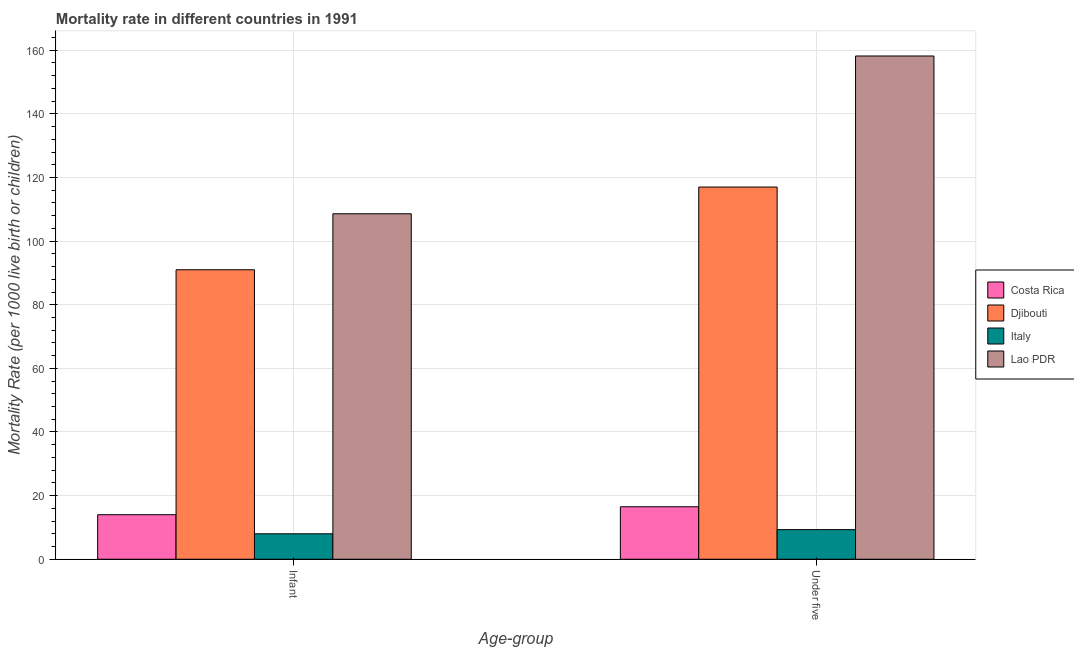How many groups of bars are there?
Provide a short and direct response. 2. Are the number of bars per tick equal to the number of legend labels?
Offer a very short reply. Yes. What is the label of the 1st group of bars from the left?
Provide a succinct answer. Infant. What is the infant mortality rate in Lao PDR?
Your response must be concise. 108.6. Across all countries, what is the maximum infant mortality rate?
Provide a succinct answer. 108.6. In which country was the under-5 mortality rate maximum?
Make the answer very short. Lao PDR. In which country was the under-5 mortality rate minimum?
Offer a terse response. Italy. What is the total under-5 mortality rate in the graph?
Keep it short and to the point. 301. What is the difference between the under-5 mortality rate in Lao PDR and the infant mortality rate in Costa Rica?
Give a very brief answer. 144.2. What is the average under-5 mortality rate per country?
Give a very brief answer. 75.25. What is the difference between the under-5 mortality rate and infant mortality rate in Lao PDR?
Your answer should be very brief. 49.6. In how many countries, is the under-5 mortality rate greater than 124 ?
Offer a very short reply. 1. What is the ratio of the under-5 mortality rate in Djibouti to that in Costa Rica?
Your response must be concise. 7.09. How many bars are there?
Provide a short and direct response. 8. Are all the bars in the graph horizontal?
Give a very brief answer. No. How many countries are there in the graph?
Offer a terse response. 4. Are the values on the major ticks of Y-axis written in scientific E-notation?
Make the answer very short. No. Where does the legend appear in the graph?
Offer a terse response. Center right. How many legend labels are there?
Provide a short and direct response. 4. How are the legend labels stacked?
Your response must be concise. Vertical. What is the title of the graph?
Ensure brevity in your answer.  Mortality rate in different countries in 1991. Does "Mali" appear as one of the legend labels in the graph?
Provide a succinct answer. No. What is the label or title of the X-axis?
Keep it short and to the point. Age-group. What is the label or title of the Y-axis?
Offer a terse response. Mortality Rate (per 1000 live birth or children). What is the Mortality Rate (per 1000 live birth or children) of Costa Rica in Infant?
Your answer should be compact. 14. What is the Mortality Rate (per 1000 live birth or children) in Djibouti in Infant?
Offer a very short reply. 91. What is the Mortality Rate (per 1000 live birth or children) of Italy in Infant?
Your response must be concise. 8. What is the Mortality Rate (per 1000 live birth or children) of Lao PDR in Infant?
Provide a short and direct response. 108.6. What is the Mortality Rate (per 1000 live birth or children) in Djibouti in Under five?
Your answer should be compact. 117. What is the Mortality Rate (per 1000 live birth or children) of Lao PDR in Under five?
Your answer should be compact. 158.2. Across all Age-group, what is the maximum Mortality Rate (per 1000 live birth or children) in Costa Rica?
Offer a terse response. 16.5. Across all Age-group, what is the maximum Mortality Rate (per 1000 live birth or children) in Djibouti?
Offer a very short reply. 117. Across all Age-group, what is the maximum Mortality Rate (per 1000 live birth or children) of Lao PDR?
Provide a short and direct response. 158.2. Across all Age-group, what is the minimum Mortality Rate (per 1000 live birth or children) in Djibouti?
Your response must be concise. 91. Across all Age-group, what is the minimum Mortality Rate (per 1000 live birth or children) of Italy?
Your response must be concise. 8. Across all Age-group, what is the minimum Mortality Rate (per 1000 live birth or children) in Lao PDR?
Offer a very short reply. 108.6. What is the total Mortality Rate (per 1000 live birth or children) of Costa Rica in the graph?
Ensure brevity in your answer.  30.5. What is the total Mortality Rate (per 1000 live birth or children) in Djibouti in the graph?
Offer a terse response. 208. What is the total Mortality Rate (per 1000 live birth or children) of Italy in the graph?
Your response must be concise. 17.3. What is the total Mortality Rate (per 1000 live birth or children) of Lao PDR in the graph?
Your answer should be very brief. 266.8. What is the difference between the Mortality Rate (per 1000 live birth or children) in Djibouti in Infant and that in Under five?
Your answer should be compact. -26. What is the difference between the Mortality Rate (per 1000 live birth or children) of Italy in Infant and that in Under five?
Your answer should be very brief. -1.3. What is the difference between the Mortality Rate (per 1000 live birth or children) in Lao PDR in Infant and that in Under five?
Ensure brevity in your answer.  -49.6. What is the difference between the Mortality Rate (per 1000 live birth or children) in Costa Rica in Infant and the Mortality Rate (per 1000 live birth or children) in Djibouti in Under five?
Your answer should be compact. -103. What is the difference between the Mortality Rate (per 1000 live birth or children) of Costa Rica in Infant and the Mortality Rate (per 1000 live birth or children) of Lao PDR in Under five?
Your answer should be very brief. -144.2. What is the difference between the Mortality Rate (per 1000 live birth or children) of Djibouti in Infant and the Mortality Rate (per 1000 live birth or children) of Italy in Under five?
Give a very brief answer. 81.7. What is the difference between the Mortality Rate (per 1000 live birth or children) in Djibouti in Infant and the Mortality Rate (per 1000 live birth or children) in Lao PDR in Under five?
Provide a short and direct response. -67.2. What is the difference between the Mortality Rate (per 1000 live birth or children) of Italy in Infant and the Mortality Rate (per 1000 live birth or children) of Lao PDR in Under five?
Your response must be concise. -150.2. What is the average Mortality Rate (per 1000 live birth or children) of Costa Rica per Age-group?
Your answer should be compact. 15.25. What is the average Mortality Rate (per 1000 live birth or children) in Djibouti per Age-group?
Offer a terse response. 104. What is the average Mortality Rate (per 1000 live birth or children) in Italy per Age-group?
Your answer should be very brief. 8.65. What is the average Mortality Rate (per 1000 live birth or children) in Lao PDR per Age-group?
Keep it short and to the point. 133.4. What is the difference between the Mortality Rate (per 1000 live birth or children) in Costa Rica and Mortality Rate (per 1000 live birth or children) in Djibouti in Infant?
Make the answer very short. -77. What is the difference between the Mortality Rate (per 1000 live birth or children) in Costa Rica and Mortality Rate (per 1000 live birth or children) in Italy in Infant?
Offer a very short reply. 6. What is the difference between the Mortality Rate (per 1000 live birth or children) of Costa Rica and Mortality Rate (per 1000 live birth or children) of Lao PDR in Infant?
Ensure brevity in your answer.  -94.6. What is the difference between the Mortality Rate (per 1000 live birth or children) of Djibouti and Mortality Rate (per 1000 live birth or children) of Italy in Infant?
Your answer should be very brief. 83. What is the difference between the Mortality Rate (per 1000 live birth or children) in Djibouti and Mortality Rate (per 1000 live birth or children) in Lao PDR in Infant?
Offer a very short reply. -17.6. What is the difference between the Mortality Rate (per 1000 live birth or children) in Italy and Mortality Rate (per 1000 live birth or children) in Lao PDR in Infant?
Your answer should be compact. -100.6. What is the difference between the Mortality Rate (per 1000 live birth or children) in Costa Rica and Mortality Rate (per 1000 live birth or children) in Djibouti in Under five?
Offer a terse response. -100.5. What is the difference between the Mortality Rate (per 1000 live birth or children) of Costa Rica and Mortality Rate (per 1000 live birth or children) of Lao PDR in Under five?
Your answer should be very brief. -141.7. What is the difference between the Mortality Rate (per 1000 live birth or children) in Djibouti and Mortality Rate (per 1000 live birth or children) in Italy in Under five?
Offer a very short reply. 107.7. What is the difference between the Mortality Rate (per 1000 live birth or children) in Djibouti and Mortality Rate (per 1000 live birth or children) in Lao PDR in Under five?
Provide a succinct answer. -41.2. What is the difference between the Mortality Rate (per 1000 live birth or children) in Italy and Mortality Rate (per 1000 live birth or children) in Lao PDR in Under five?
Keep it short and to the point. -148.9. What is the ratio of the Mortality Rate (per 1000 live birth or children) in Costa Rica in Infant to that in Under five?
Your answer should be very brief. 0.85. What is the ratio of the Mortality Rate (per 1000 live birth or children) in Djibouti in Infant to that in Under five?
Keep it short and to the point. 0.78. What is the ratio of the Mortality Rate (per 1000 live birth or children) of Italy in Infant to that in Under five?
Give a very brief answer. 0.86. What is the ratio of the Mortality Rate (per 1000 live birth or children) in Lao PDR in Infant to that in Under five?
Keep it short and to the point. 0.69. What is the difference between the highest and the second highest Mortality Rate (per 1000 live birth or children) in Italy?
Your answer should be very brief. 1.3. What is the difference between the highest and the second highest Mortality Rate (per 1000 live birth or children) of Lao PDR?
Provide a succinct answer. 49.6. What is the difference between the highest and the lowest Mortality Rate (per 1000 live birth or children) in Costa Rica?
Keep it short and to the point. 2.5. What is the difference between the highest and the lowest Mortality Rate (per 1000 live birth or children) in Lao PDR?
Ensure brevity in your answer.  49.6. 